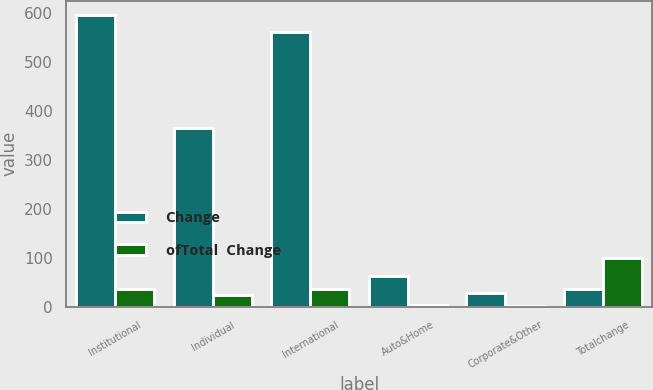Convert chart. <chart><loc_0><loc_0><loc_500><loc_500><stacked_bar_chart><ecel><fcel>Institutional<fcel>Individual<fcel>International<fcel>Auto&Home<fcel>Corporate&Other<fcel>Totalchange<nl><fcel>Change<fcel>594<fcel>365<fcel>560<fcel>63<fcel>27<fcel>36<nl><fcel>ofTotal  Change<fcel>36<fcel>23<fcel>35<fcel>4<fcel>2<fcel>100<nl></chart> 